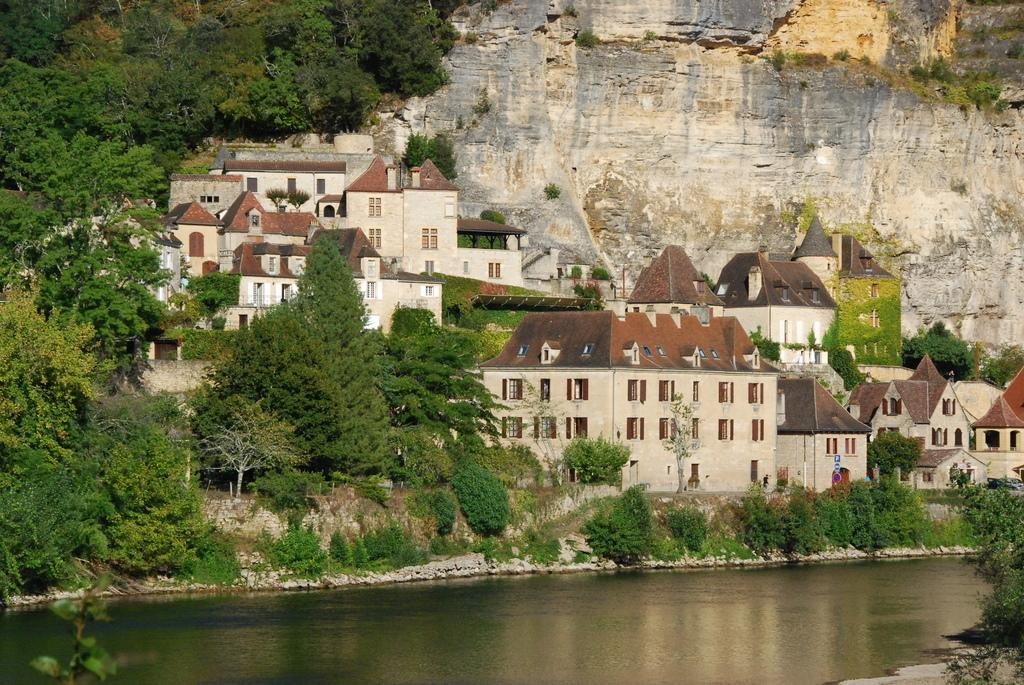What is visible in the image? Water, buildings, and trees are visible in the image. Can you describe the water in the image? The water is visible in the image, but its specific characteristics are not mentioned in the provided facts. What type of structures can be seen in the image? There are buildings in the image. What type of vegetation is present in the image? There are trees in the image. What type of mouth can be seen on the trees in the image? There is no mention of mouths on the trees in the image or the provided facts. What process is being carried out by the water in the image? The provided facts do not mention any specific process being carried out by the water in the image. 